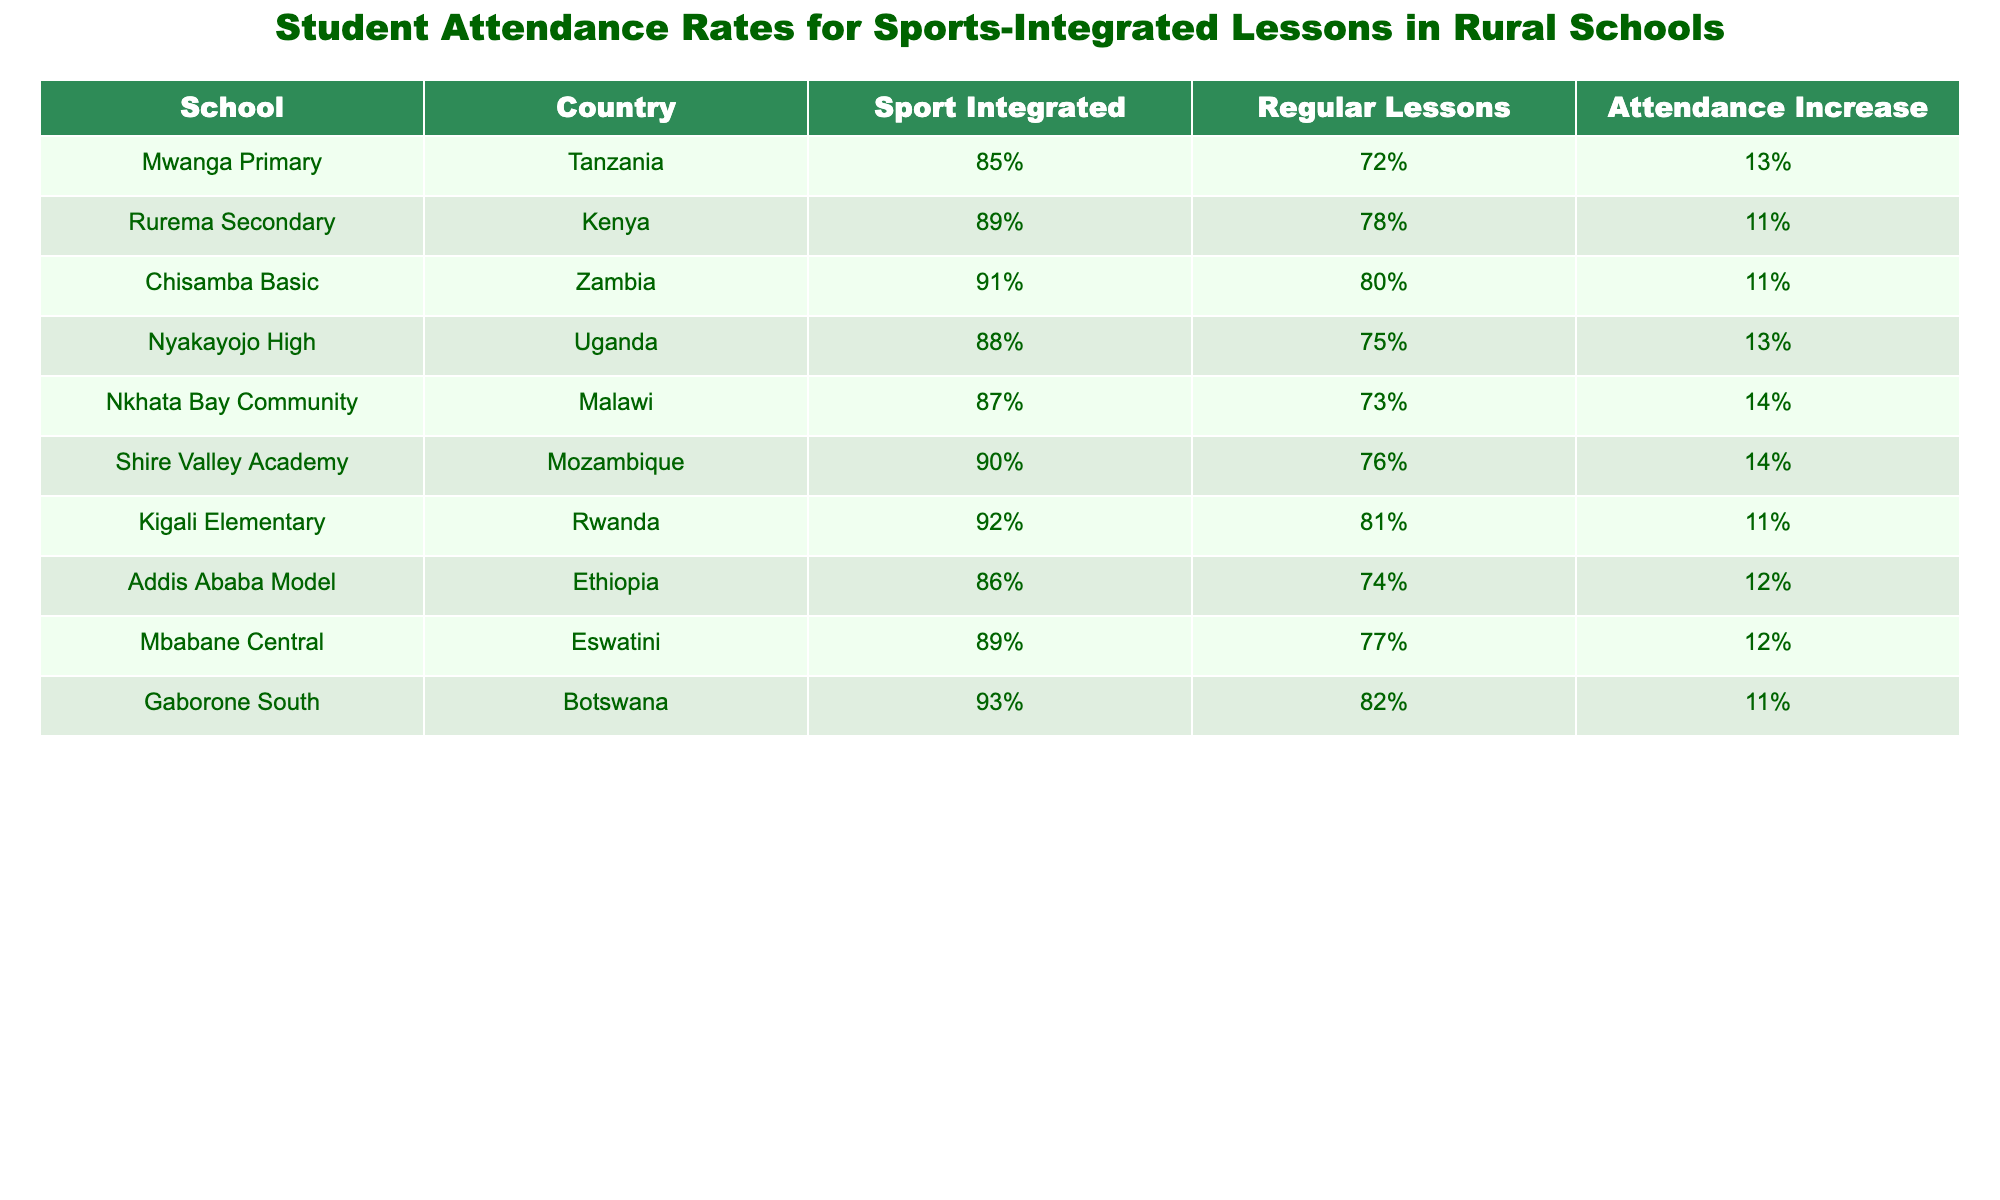What is the attendance increase percentage at Mwanga Primary? The attendance increase percentage for Mwanga Primary can be found in the "Attendance Increase" column corresponding to the "Mwanga Primary" row, which is 13%.
Answer: 13% Which school in Kenya has the highest attendance rate for sports-integrated lessons? In the table, the school in Kenya that shows the highest attendance rate for sports-integrated lessons is Rurema Secondary, which has an attendance rate of 89%.
Answer: Rurema Secondary How many schools reported an attendance increase of 14%? By examining the "Attendance Increase" column, we find that Nkhata Bay Community and Shire Valley Academy are the two schools that reported an attendance increase of 14%. Therefore, there are 2 schools.
Answer: 2 What is the average attendance rate for sports-integrated lessons across all schools listed? To find the average attendance rate, we first add the attendance rates: 85 + 89 + 91 + 88 + 87 + 90 + 92 + 86 + 89 + 93 = 889. Dividing this by the number of schools (10), we get 889 / 10 = 88.9%.
Answer: 88.9% Is it true that all schools have an attendance increase greater than 10%? By examining the "Attendance Increase" column, we find that all schools do indeed have attendance increases of 11% or higher, so the statement is true.
Answer: Yes Which country had the lowest attendance rate for regular lessons among the schools listed? By looking at the "Regular Lessons" column, the lowest attendance rate for regular lessons is found in Ethiopia, where the rate is 74%.
Answer: Ethiopia Do any schools have both an attendance rate for sports-integrated lessons and regular lessons above 90%? Checking the table, we see that Gaborone South has a sports-integrated attendance rate of 93% and a regular lesson attendance rate of 82%, while Kigali Elementary has a sports-integrated rate of 92% and a regular lesson rate of 81%. Therefore, the answer is no; none have both rates above 90%.
Answer: No Which school has the second lowest attendance increase percentage? Looking through the "Attendance Increase" column, we can see that the attendance increase percentages are 11%, 11%, 12%, and 13%. The second lowest is 11%, which is shared by Rurema Secondary and Chisamba Basic. Therefore, there are two schools sharing this percentage, making them the second lowest.
Answer: Rurema Secondary and Chisamba Basic 